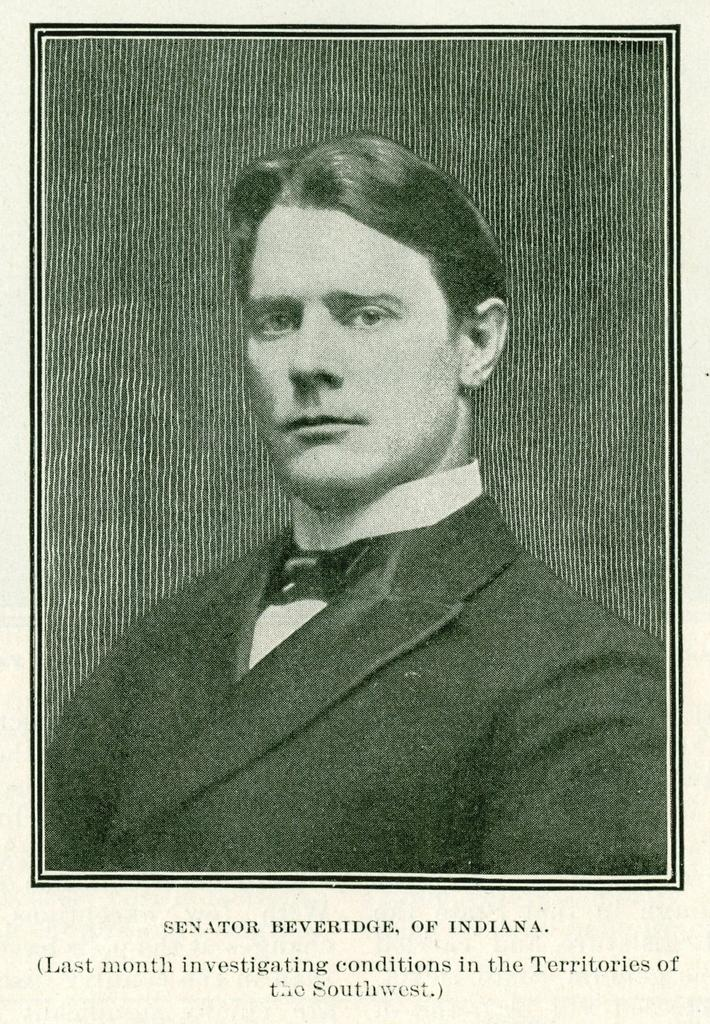What can be found at the bottom of the poster? There is text at the bottom of the poster. What is the main subject in the foreground of the poster? There is an image of a man in the foreground of the poster. What type of disease is the man suffering from in the image? There is no indication of any disease in the image; it only shows an image of a man and text at the bottom. 